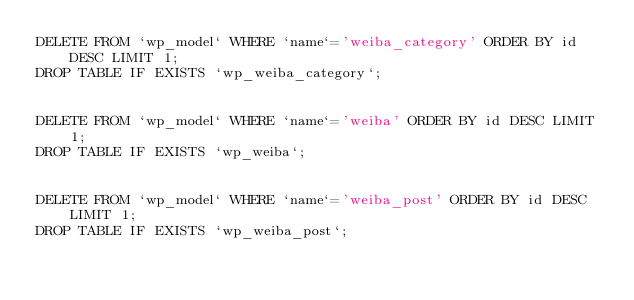Convert code to text. <code><loc_0><loc_0><loc_500><loc_500><_SQL_>DELETE FROM `wp_model` WHERE `name`='weiba_category' ORDER BY id DESC LIMIT 1;
DROP TABLE IF EXISTS `wp_weiba_category`;


DELETE FROM `wp_model` WHERE `name`='weiba' ORDER BY id DESC LIMIT 1;
DROP TABLE IF EXISTS `wp_weiba`;


DELETE FROM `wp_model` WHERE `name`='weiba_post' ORDER BY id DESC LIMIT 1;
DROP TABLE IF EXISTS `wp_weiba_post`;


</code> 